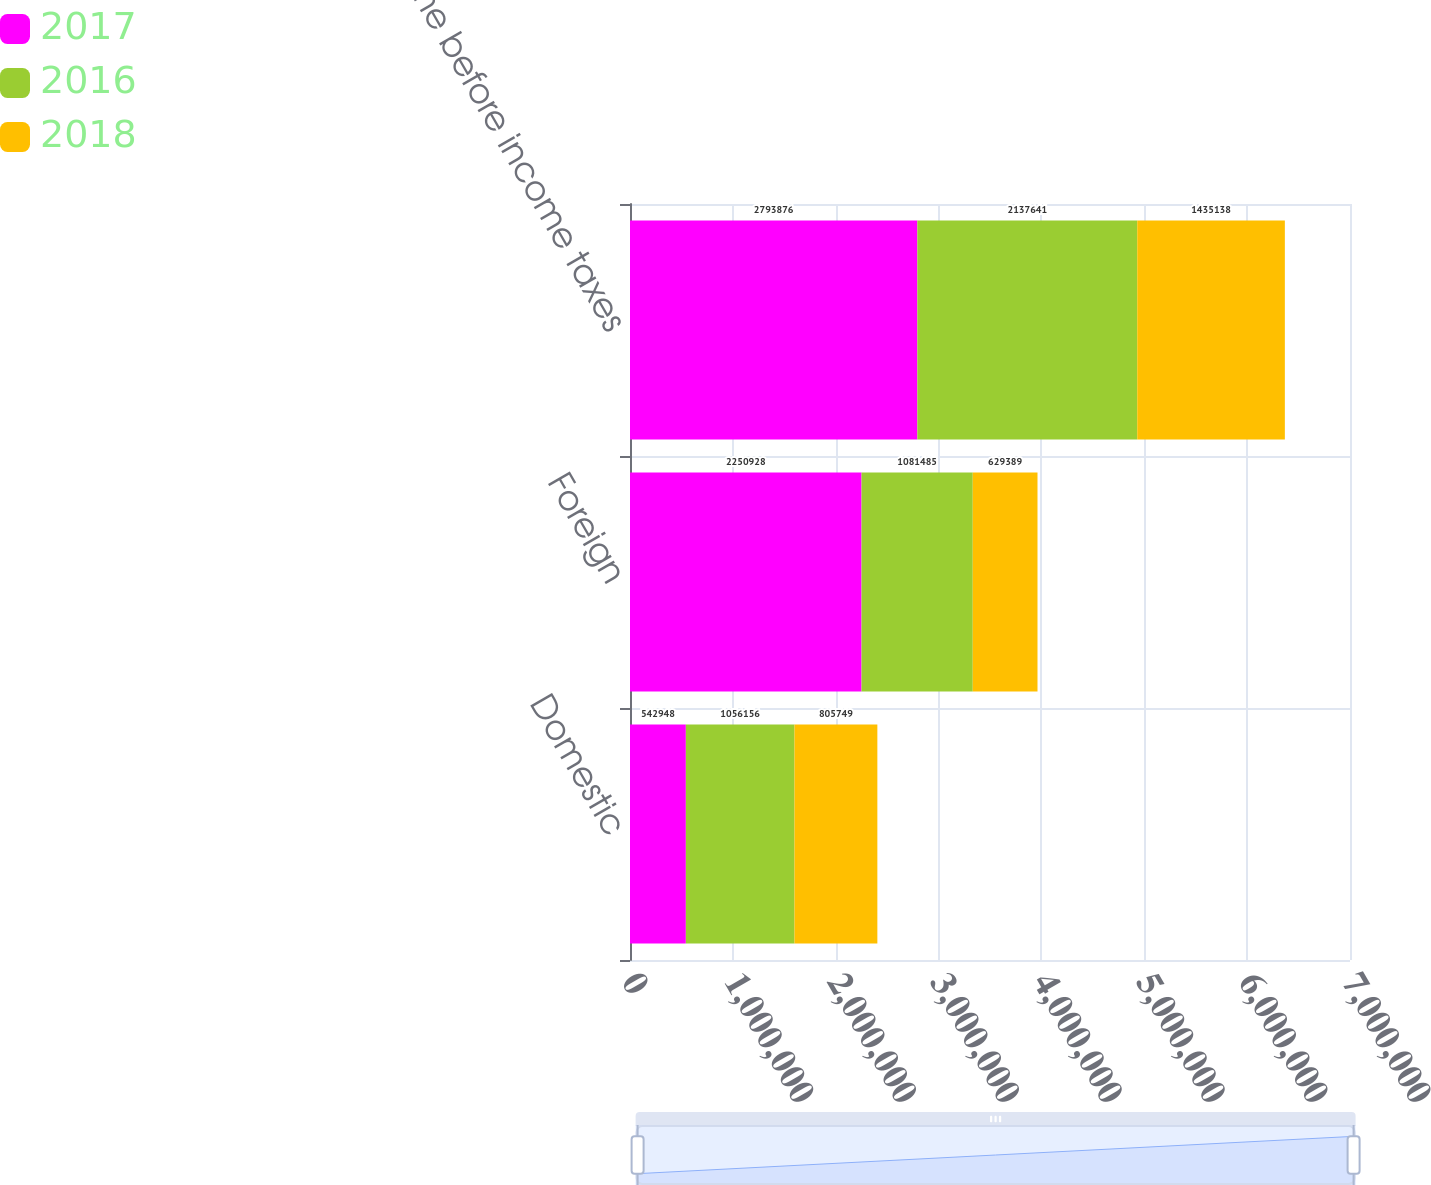Convert chart to OTSL. <chart><loc_0><loc_0><loc_500><loc_500><stacked_bar_chart><ecel><fcel>Domestic<fcel>Foreign<fcel>Income before income taxes<nl><fcel>2017<fcel>542948<fcel>2.25093e+06<fcel>2.79388e+06<nl><fcel>2016<fcel>1.05616e+06<fcel>1.08148e+06<fcel>2.13764e+06<nl><fcel>2018<fcel>805749<fcel>629389<fcel>1.43514e+06<nl></chart> 